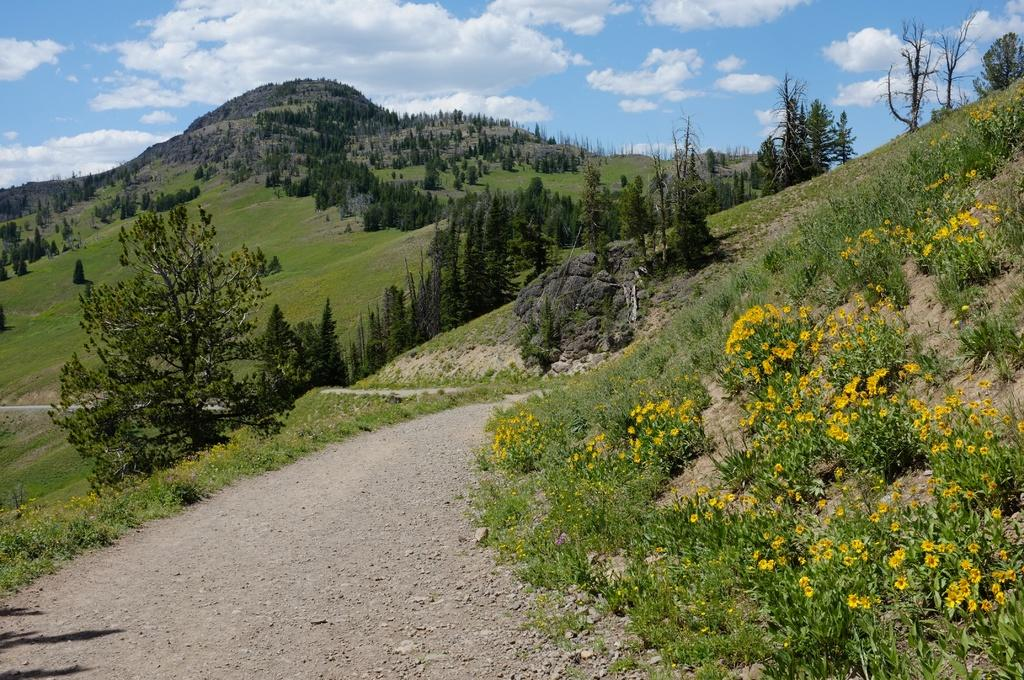What type of plants can be seen in the image? There are flower plants in the image. What color are the flowers on the plants? A: The flowers are yellow in color. What type of vegetation is visible in the image besides the flower plants? There is grass visible in the image. What else can be seen in the background of the image? There are trees and the sky visible in the background of the image. How many spiders are crawling on the flowers in the image? There are no spiders visible in the image; it only features flower plants, grass, trees, and the sky. 